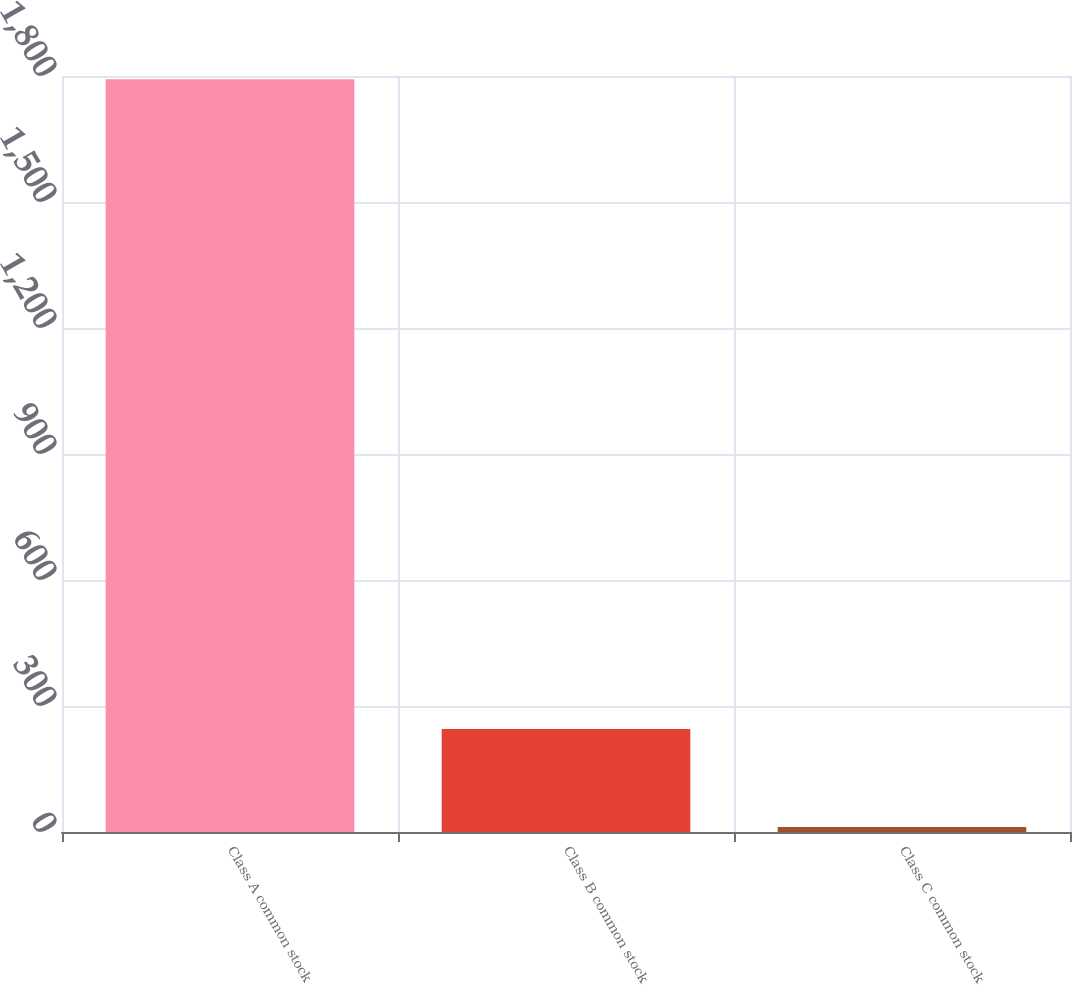Convert chart. <chart><loc_0><loc_0><loc_500><loc_500><bar_chart><fcel>Class A common stock<fcel>Class B common stock<fcel>Class C common stock<nl><fcel>1792<fcel>245<fcel>12<nl></chart> 